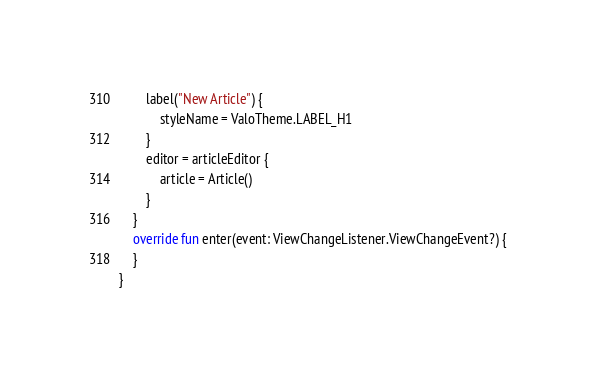Convert code to text. <code><loc_0><loc_0><loc_500><loc_500><_Kotlin_>        label("New Article") {
            styleName = ValoTheme.LABEL_H1
        }
        editor = articleEditor {
            article = Article()
        }
    }
    override fun enter(event: ViewChangeListener.ViewChangeEvent?) {
    }
}
</code> 